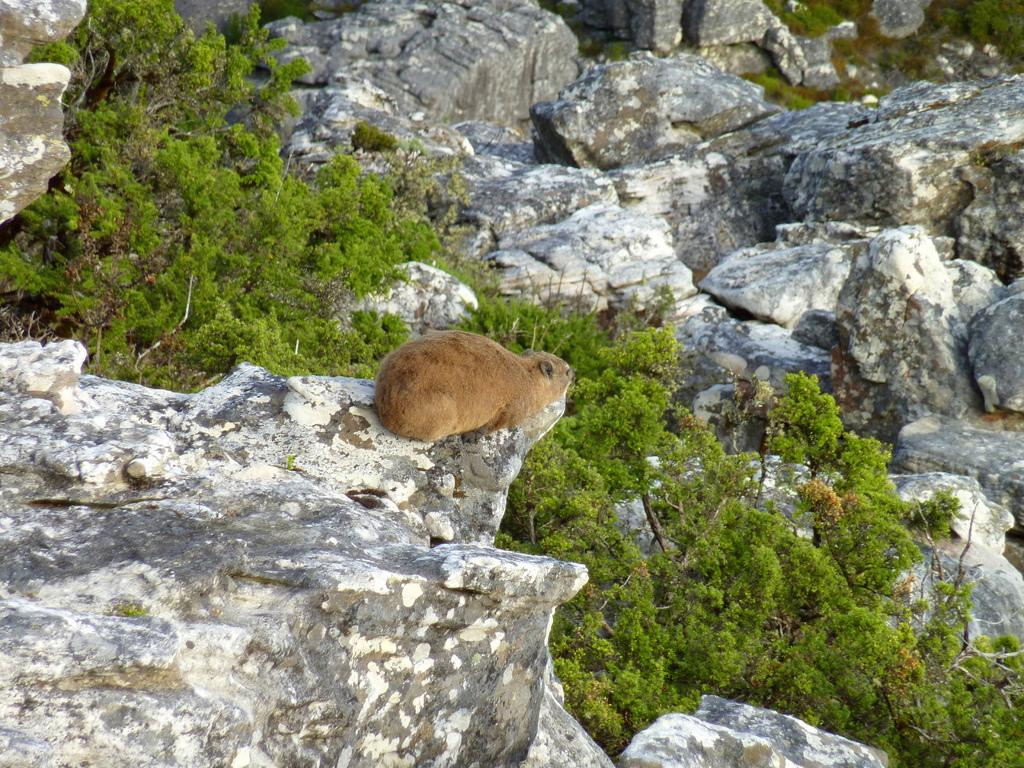What type of animal can be seen in the image? There is an animal in the image, and it is brown in color. Where is the animal located in the image? The animal is sitting on the edge of a rock. What can be seen in the background of the image? There are trees and rocks visible in the background of the image. How many pigs are holding a nail and a cabbage in the image? There are no pigs, nails, or cabbages present in the image. 